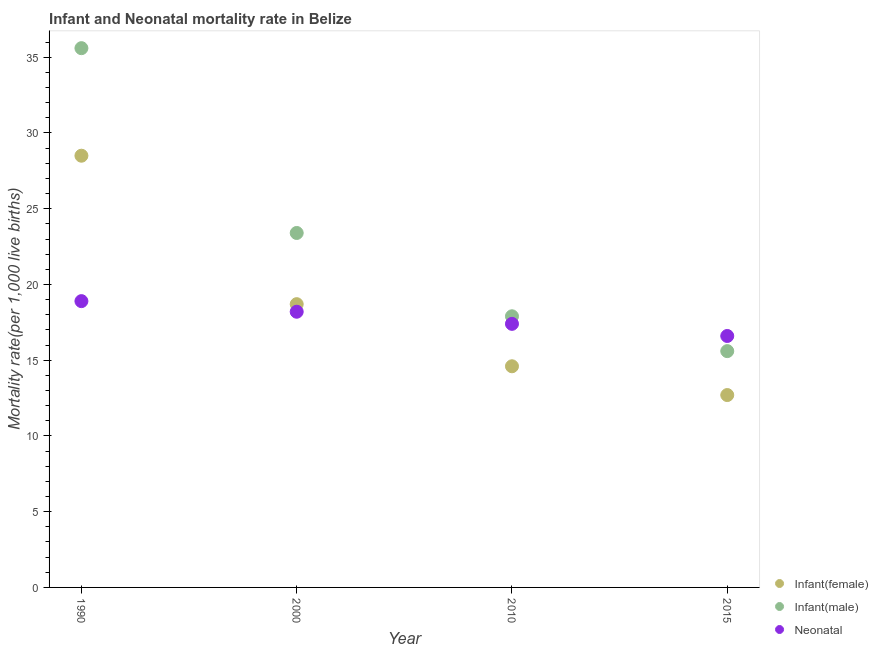How many different coloured dotlines are there?
Offer a terse response. 3. Is the number of dotlines equal to the number of legend labels?
Provide a succinct answer. Yes. Across all years, what is the maximum infant mortality rate(male)?
Your answer should be very brief. 35.6. In which year was the neonatal mortality rate maximum?
Your answer should be compact. 1990. In which year was the neonatal mortality rate minimum?
Give a very brief answer. 2015. What is the total infant mortality rate(female) in the graph?
Give a very brief answer. 74.5. What is the difference between the neonatal mortality rate in 2010 and the infant mortality rate(male) in 2015?
Your answer should be very brief. 1.8. What is the average infant mortality rate(male) per year?
Make the answer very short. 23.12. In the year 2010, what is the difference between the infant mortality rate(female) and neonatal mortality rate?
Give a very brief answer. -2.8. What is the ratio of the infant mortality rate(male) in 1990 to that in 2000?
Make the answer very short. 1.52. Is the infant mortality rate(male) in 2000 less than that in 2015?
Your response must be concise. No. Is the difference between the neonatal mortality rate in 1990 and 2010 greater than the difference between the infant mortality rate(male) in 1990 and 2010?
Make the answer very short. No. What is the difference between the highest and the second highest neonatal mortality rate?
Your response must be concise. 0.7. In how many years, is the infant mortality rate(male) greater than the average infant mortality rate(male) taken over all years?
Your response must be concise. 2. Is the sum of the neonatal mortality rate in 1990 and 2010 greater than the maximum infant mortality rate(male) across all years?
Your answer should be very brief. Yes. Is it the case that in every year, the sum of the infant mortality rate(female) and infant mortality rate(male) is greater than the neonatal mortality rate?
Make the answer very short. Yes. Is the infant mortality rate(female) strictly greater than the infant mortality rate(male) over the years?
Offer a terse response. No. Is the infant mortality rate(female) strictly less than the neonatal mortality rate over the years?
Keep it short and to the point. No. How many dotlines are there?
Ensure brevity in your answer.  3. How many years are there in the graph?
Keep it short and to the point. 4. Are the values on the major ticks of Y-axis written in scientific E-notation?
Offer a very short reply. No. Does the graph contain any zero values?
Provide a short and direct response. No. How many legend labels are there?
Provide a succinct answer. 3. How are the legend labels stacked?
Your answer should be very brief. Vertical. What is the title of the graph?
Give a very brief answer. Infant and Neonatal mortality rate in Belize. Does "Ireland" appear as one of the legend labels in the graph?
Give a very brief answer. No. What is the label or title of the X-axis?
Your response must be concise. Year. What is the label or title of the Y-axis?
Your answer should be compact. Mortality rate(per 1,0 live births). What is the Mortality rate(per 1,000 live births) of Infant(male) in 1990?
Provide a short and direct response. 35.6. What is the Mortality rate(per 1,000 live births) of Infant(female) in 2000?
Your response must be concise. 18.7. What is the Mortality rate(per 1,000 live births) in Infant(male) in 2000?
Your answer should be compact. 23.4. What is the Mortality rate(per 1,000 live births) in Infant(male) in 2015?
Ensure brevity in your answer.  15.6. What is the Mortality rate(per 1,000 live births) in Neonatal  in 2015?
Offer a terse response. 16.6. Across all years, what is the maximum Mortality rate(per 1,000 live births) in Infant(male)?
Give a very brief answer. 35.6. Across all years, what is the minimum Mortality rate(per 1,000 live births) in Neonatal ?
Offer a terse response. 16.6. What is the total Mortality rate(per 1,000 live births) of Infant(female) in the graph?
Give a very brief answer. 74.5. What is the total Mortality rate(per 1,000 live births) of Infant(male) in the graph?
Make the answer very short. 92.5. What is the total Mortality rate(per 1,000 live births) of Neonatal  in the graph?
Provide a short and direct response. 71.1. What is the difference between the Mortality rate(per 1,000 live births) of Infant(female) in 1990 and that in 2000?
Your answer should be very brief. 9.8. What is the difference between the Mortality rate(per 1,000 live births) in Infant(male) in 1990 and that in 2000?
Make the answer very short. 12.2. What is the difference between the Mortality rate(per 1,000 live births) of Neonatal  in 1990 and that in 2000?
Your answer should be very brief. 0.7. What is the difference between the Mortality rate(per 1,000 live births) of Infant(female) in 1990 and that in 2010?
Keep it short and to the point. 13.9. What is the difference between the Mortality rate(per 1,000 live births) in Neonatal  in 1990 and that in 2010?
Provide a succinct answer. 1.5. What is the difference between the Mortality rate(per 1,000 live births) in Infant(female) in 1990 and that in 2015?
Offer a very short reply. 15.8. What is the difference between the Mortality rate(per 1,000 live births) of Neonatal  in 1990 and that in 2015?
Make the answer very short. 2.3. What is the difference between the Mortality rate(per 1,000 live births) of Infant(male) in 2000 and that in 2010?
Keep it short and to the point. 5.5. What is the difference between the Mortality rate(per 1,000 live births) in Infant(male) in 2000 and that in 2015?
Provide a succinct answer. 7.8. What is the difference between the Mortality rate(per 1,000 live births) in Neonatal  in 2000 and that in 2015?
Ensure brevity in your answer.  1.6. What is the difference between the Mortality rate(per 1,000 live births) of Infant(female) in 1990 and the Mortality rate(per 1,000 live births) of Infant(male) in 2000?
Keep it short and to the point. 5.1. What is the difference between the Mortality rate(per 1,000 live births) of Infant(female) in 1990 and the Mortality rate(per 1,000 live births) of Neonatal  in 2000?
Offer a terse response. 10.3. What is the difference between the Mortality rate(per 1,000 live births) in Infant(female) in 1990 and the Mortality rate(per 1,000 live births) in Infant(male) in 2010?
Ensure brevity in your answer.  10.6. What is the difference between the Mortality rate(per 1,000 live births) of Infant(male) in 1990 and the Mortality rate(per 1,000 live births) of Neonatal  in 2010?
Ensure brevity in your answer.  18.2. What is the difference between the Mortality rate(per 1,000 live births) in Infant(female) in 1990 and the Mortality rate(per 1,000 live births) in Infant(male) in 2015?
Ensure brevity in your answer.  12.9. What is the difference between the Mortality rate(per 1,000 live births) in Infant(female) in 1990 and the Mortality rate(per 1,000 live births) in Neonatal  in 2015?
Make the answer very short. 11.9. What is the difference between the Mortality rate(per 1,000 live births) of Infant(male) in 1990 and the Mortality rate(per 1,000 live births) of Neonatal  in 2015?
Keep it short and to the point. 19. What is the difference between the Mortality rate(per 1,000 live births) in Infant(male) in 2000 and the Mortality rate(per 1,000 live births) in Neonatal  in 2010?
Offer a very short reply. 6. What is the difference between the Mortality rate(per 1,000 live births) in Infant(male) in 2000 and the Mortality rate(per 1,000 live births) in Neonatal  in 2015?
Ensure brevity in your answer.  6.8. What is the difference between the Mortality rate(per 1,000 live births) in Infant(female) in 2010 and the Mortality rate(per 1,000 live births) in Infant(male) in 2015?
Ensure brevity in your answer.  -1. What is the difference between the Mortality rate(per 1,000 live births) of Infant(female) in 2010 and the Mortality rate(per 1,000 live births) of Neonatal  in 2015?
Your response must be concise. -2. What is the difference between the Mortality rate(per 1,000 live births) of Infant(male) in 2010 and the Mortality rate(per 1,000 live births) of Neonatal  in 2015?
Your answer should be compact. 1.3. What is the average Mortality rate(per 1,000 live births) in Infant(female) per year?
Your response must be concise. 18.62. What is the average Mortality rate(per 1,000 live births) in Infant(male) per year?
Your response must be concise. 23.12. What is the average Mortality rate(per 1,000 live births) of Neonatal  per year?
Your answer should be compact. 17.77. In the year 1990, what is the difference between the Mortality rate(per 1,000 live births) of Infant(female) and Mortality rate(per 1,000 live births) of Infant(male)?
Give a very brief answer. -7.1. In the year 1990, what is the difference between the Mortality rate(per 1,000 live births) of Infant(female) and Mortality rate(per 1,000 live births) of Neonatal ?
Offer a very short reply. 9.6. In the year 1990, what is the difference between the Mortality rate(per 1,000 live births) in Infant(male) and Mortality rate(per 1,000 live births) in Neonatal ?
Offer a very short reply. 16.7. In the year 2000, what is the difference between the Mortality rate(per 1,000 live births) in Infant(female) and Mortality rate(per 1,000 live births) in Neonatal ?
Provide a short and direct response. 0.5. In the year 2000, what is the difference between the Mortality rate(per 1,000 live births) in Infant(male) and Mortality rate(per 1,000 live births) in Neonatal ?
Your answer should be very brief. 5.2. In the year 2010, what is the difference between the Mortality rate(per 1,000 live births) in Infant(female) and Mortality rate(per 1,000 live births) in Neonatal ?
Ensure brevity in your answer.  -2.8. In the year 2015, what is the difference between the Mortality rate(per 1,000 live births) of Infant(female) and Mortality rate(per 1,000 live births) of Infant(male)?
Make the answer very short. -2.9. In the year 2015, what is the difference between the Mortality rate(per 1,000 live births) of Infant(male) and Mortality rate(per 1,000 live births) of Neonatal ?
Your response must be concise. -1. What is the ratio of the Mortality rate(per 1,000 live births) of Infant(female) in 1990 to that in 2000?
Provide a succinct answer. 1.52. What is the ratio of the Mortality rate(per 1,000 live births) of Infant(male) in 1990 to that in 2000?
Offer a very short reply. 1.52. What is the ratio of the Mortality rate(per 1,000 live births) of Neonatal  in 1990 to that in 2000?
Keep it short and to the point. 1.04. What is the ratio of the Mortality rate(per 1,000 live births) of Infant(female) in 1990 to that in 2010?
Your response must be concise. 1.95. What is the ratio of the Mortality rate(per 1,000 live births) of Infant(male) in 1990 to that in 2010?
Make the answer very short. 1.99. What is the ratio of the Mortality rate(per 1,000 live births) in Neonatal  in 1990 to that in 2010?
Ensure brevity in your answer.  1.09. What is the ratio of the Mortality rate(per 1,000 live births) of Infant(female) in 1990 to that in 2015?
Keep it short and to the point. 2.24. What is the ratio of the Mortality rate(per 1,000 live births) of Infant(male) in 1990 to that in 2015?
Offer a terse response. 2.28. What is the ratio of the Mortality rate(per 1,000 live births) in Neonatal  in 1990 to that in 2015?
Ensure brevity in your answer.  1.14. What is the ratio of the Mortality rate(per 1,000 live births) in Infant(female) in 2000 to that in 2010?
Ensure brevity in your answer.  1.28. What is the ratio of the Mortality rate(per 1,000 live births) in Infant(male) in 2000 to that in 2010?
Give a very brief answer. 1.31. What is the ratio of the Mortality rate(per 1,000 live births) of Neonatal  in 2000 to that in 2010?
Provide a succinct answer. 1.05. What is the ratio of the Mortality rate(per 1,000 live births) of Infant(female) in 2000 to that in 2015?
Keep it short and to the point. 1.47. What is the ratio of the Mortality rate(per 1,000 live births) in Neonatal  in 2000 to that in 2015?
Your response must be concise. 1.1. What is the ratio of the Mortality rate(per 1,000 live births) in Infant(female) in 2010 to that in 2015?
Ensure brevity in your answer.  1.15. What is the ratio of the Mortality rate(per 1,000 live births) in Infant(male) in 2010 to that in 2015?
Ensure brevity in your answer.  1.15. What is the ratio of the Mortality rate(per 1,000 live births) of Neonatal  in 2010 to that in 2015?
Provide a succinct answer. 1.05. What is the difference between the highest and the lowest Mortality rate(per 1,000 live births) of Infant(female)?
Provide a short and direct response. 15.8. What is the difference between the highest and the lowest Mortality rate(per 1,000 live births) of Infant(male)?
Ensure brevity in your answer.  20. 